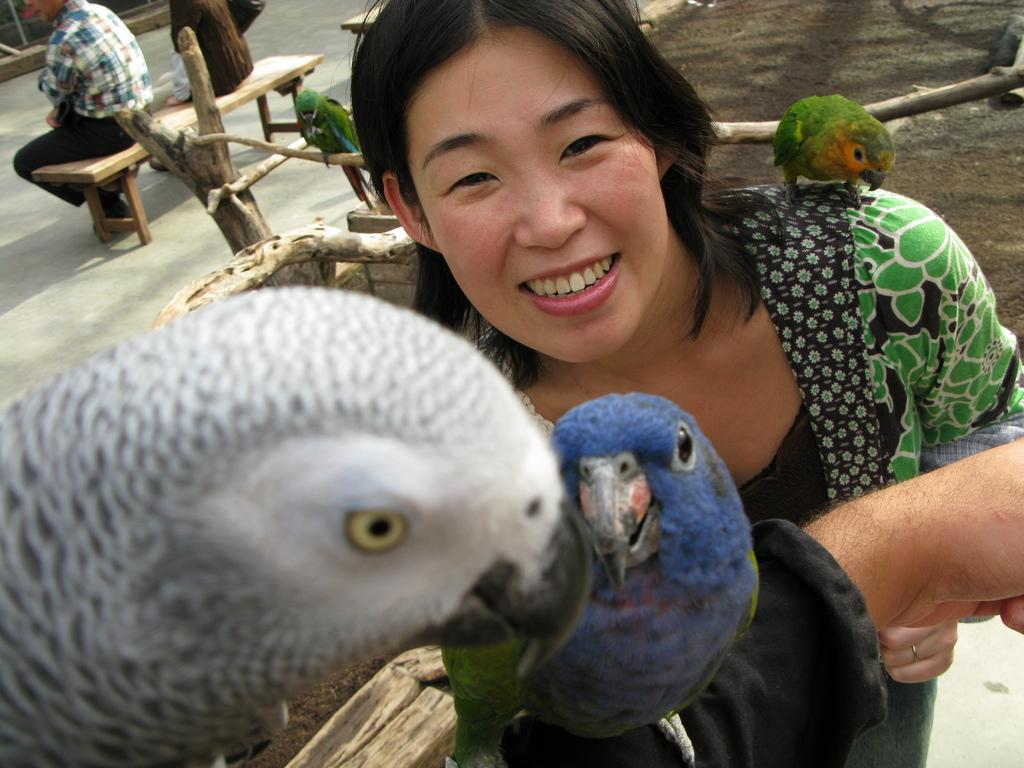What type of animals can be seen in the image? There are birds in the image. How many people are present in the image? There are three persons in the image. What are two of the persons doing in the image? Two of the persons are sitting on a bench. What object can be seen in the image that is made of wood? There is a tree trunk in the image. What grade does the person sitting on the bench receive for their performance in the image? There is no indication of a performance or grading system in the image, so it cannot be determined. 